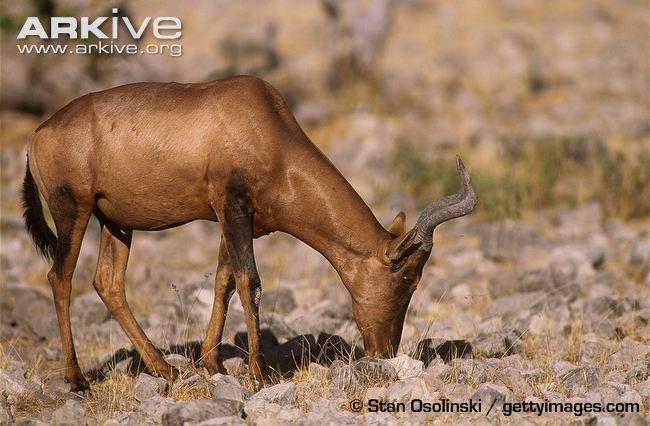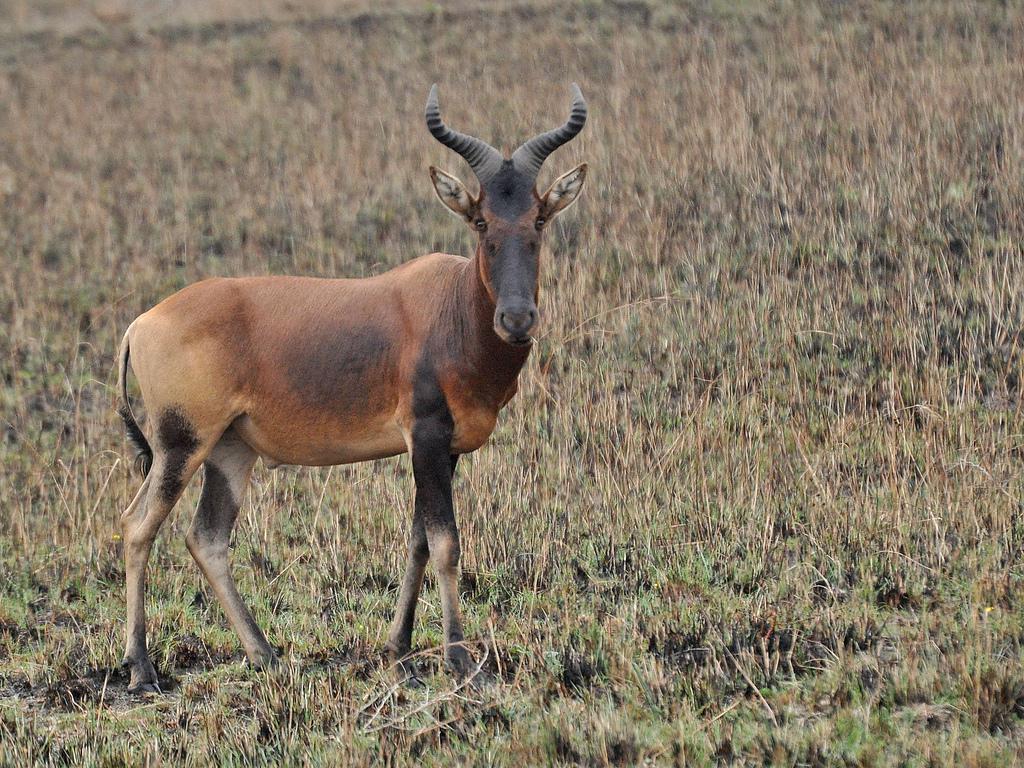The first image is the image on the left, the second image is the image on the right. Considering the images on both sides, is "Exactly one animal is pointed left." valid? Answer yes or no. No. The first image is the image on the left, the second image is the image on the right. Evaluate the accuracy of this statement regarding the images: "Each image contains only one horned animal, and the animal in the right image stands in profile turned leftward.". Is it true? Answer yes or no. No. 